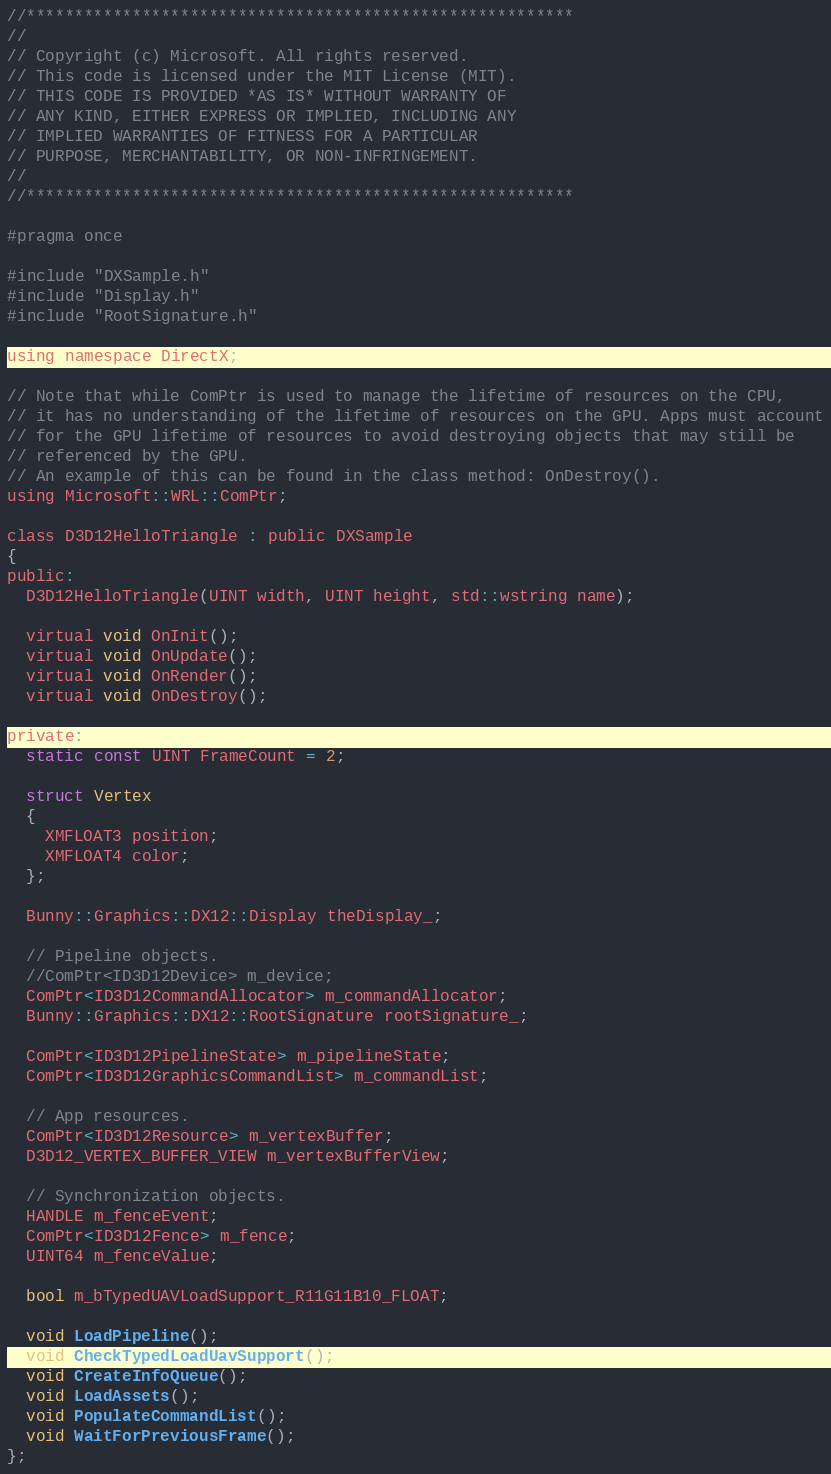<code> <loc_0><loc_0><loc_500><loc_500><_C_>//*********************************************************
//
// Copyright (c) Microsoft. All rights reserved.
// This code is licensed under the MIT License (MIT).
// THIS CODE IS PROVIDED *AS IS* WITHOUT WARRANTY OF
// ANY KIND, EITHER EXPRESS OR IMPLIED, INCLUDING ANY
// IMPLIED WARRANTIES OF FITNESS FOR A PARTICULAR
// PURPOSE, MERCHANTABILITY, OR NON-INFRINGEMENT.
//
//*********************************************************

#pragma once

#include "DXSample.h"
#include "Display.h"
#include "RootSignature.h"

using namespace DirectX;

// Note that while ComPtr is used to manage the lifetime of resources on the CPU,
// it has no understanding of the lifetime of resources on the GPU. Apps must account
// for the GPU lifetime of resources to avoid destroying objects that may still be
// referenced by the GPU.
// An example of this can be found in the class method: OnDestroy().
using Microsoft::WRL::ComPtr;

class D3D12HelloTriangle : public DXSample
{
public:
  D3D12HelloTriangle(UINT width, UINT height, std::wstring name);

  virtual void OnInit();
  virtual void OnUpdate();
  virtual void OnRender();
  virtual void OnDestroy();

private:
  static const UINT FrameCount = 2;

  struct Vertex
  {
    XMFLOAT3 position;
    XMFLOAT4 color;
  };

  Bunny::Graphics::DX12::Display theDisplay_;

  // Pipeline objects. 
  //ComPtr<ID3D12Device> m_device;
  ComPtr<ID3D12CommandAllocator> m_commandAllocator;  
  Bunny::Graphics::DX12::RootSignature rootSignature_;

  ComPtr<ID3D12PipelineState> m_pipelineState;
  ComPtr<ID3D12GraphicsCommandList> m_commandList;

  // App resources.
  ComPtr<ID3D12Resource> m_vertexBuffer;
  D3D12_VERTEX_BUFFER_VIEW m_vertexBufferView;

  // Synchronization objects.
  HANDLE m_fenceEvent;
  ComPtr<ID3D12Fence> m_fence;
  UINT64 m_fenceValue;

  bool m_bTypedUAVLoadSupport_R11G11B10_FLOAT;

  void LoadPipeline();
  void CheckTypedLoadUavSupport();
  void CreateInfoQueue();
  void LoadAssets();
  void PopulateCommandList();
  void WaitForPreviousFrame();
};</code> 